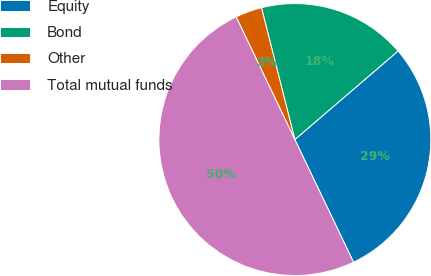<chart> <loc_0><loc_0><loc_500><loc_500><pie_chart><fcel>Equity<fcel>Bond<fcel>Other<fcel>Total mutual funds<nl><fcel>29.18%<fcel>17.66%<fcel>3.16%<fcel>50.0%<nl></chart> 